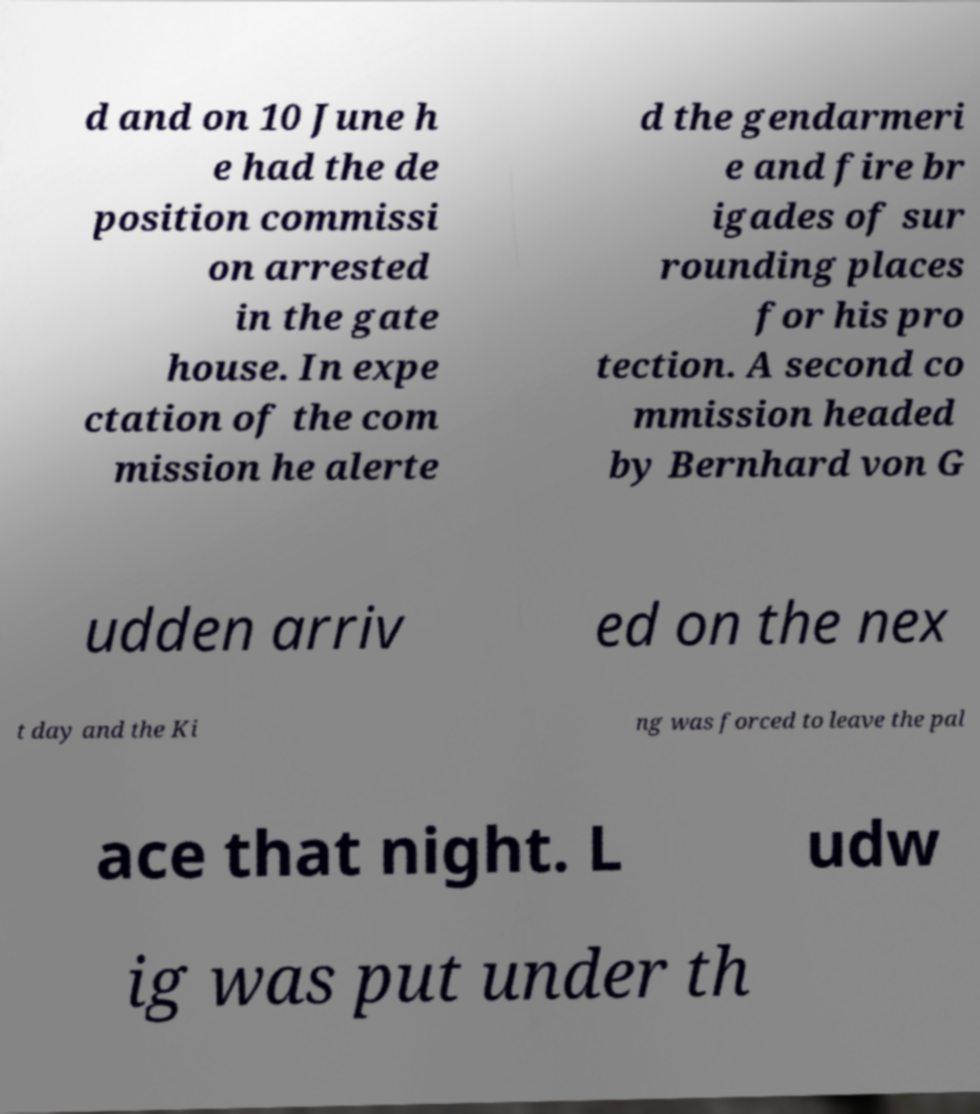Could you extract and type out the text from this image? d and on 10 June h e had the de position commissi on arrested in the gate house. In expe ctation of the com mission he alerte d the gendarmeri e and fire br igades of sur rounding places for his pro tection. A second co mmission headed by Bernhard von G udden arriv ed on the nex t day and the Ki ng was forced to leave the pal ace that night. L udw ig was put under th 